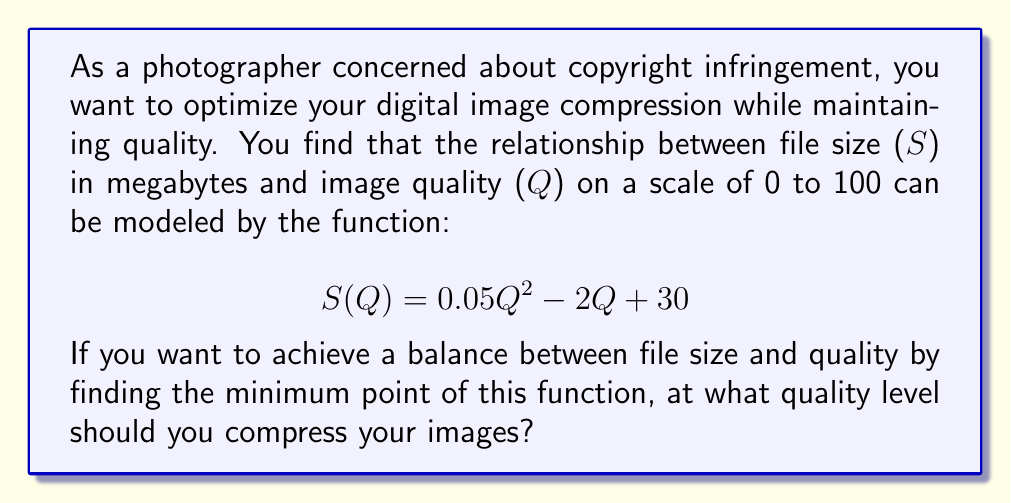Could you help me with this problem? To find the optimal quality level for compression, we need to determine the minimum point of the given quadratic function. This can be done by following these steps:

1. The function is in the form of a quadratic equation:
   $$S(Q) = 0.05Q^2 - 2Q + 30$$

2. For a quadratic function $f(x) = ax^2 + bx + c$, the x-coordinate of the vertex (which represents the minimum or maximum point) is given by the formula:
   $$x = -\frac{b}{2a}$$

3. In our case, $a = 0.05$, $b = -2$, and $c = 30$. Let's substitute these values:
   $$Q = -\frac{(-2)}{2(0.05)} = \frac{2}{0.1} = 20$$

4. To confirm this is a minimum point (rather than a maximum), we can check that $a > 0$, which it is (0.05 > 0).

5. Therefore, the quality level that minimizes the file size while maintaining an optimal balance with image quality is 20 on the scale of 0 to 100.

This approach allows you to compress your images efficiently, reducing file size and potentially deterring unauthorized use, while still maintaining a reasonable level of quality for your artistic work.
Answer: 20 